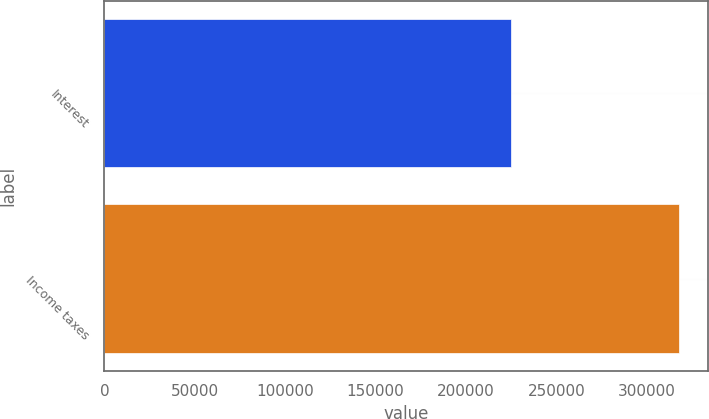<chart> <loc_0><loc_0><loc_500><loc_500><bar_chart><fcel>Interest<fcel>Income taxes<nl><fcel>225228<fcel>317812<nl></chart> 